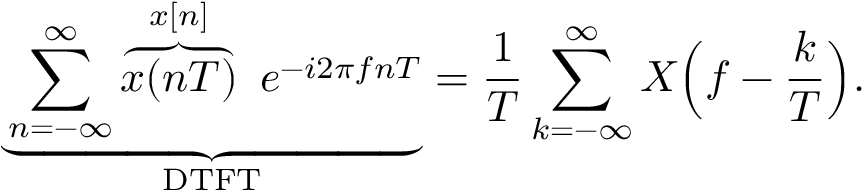Convert formula to latex. <formula><loc_0><loc_0><loc_500><loc_500>\underbrace { \sum _ { n = - \infty } ^ { \infty } \overbrace { x ( n T ) } ^ { x [ n ] } \ e ^ { - i 2 \pi f n T } } _ { D T F T } = { \frac { 1 } { T } } \sum _ { k = - \infty } ^ { \infty } X { \left ( } f - { \frac { k } { T } } { \right ) } .</formula> 